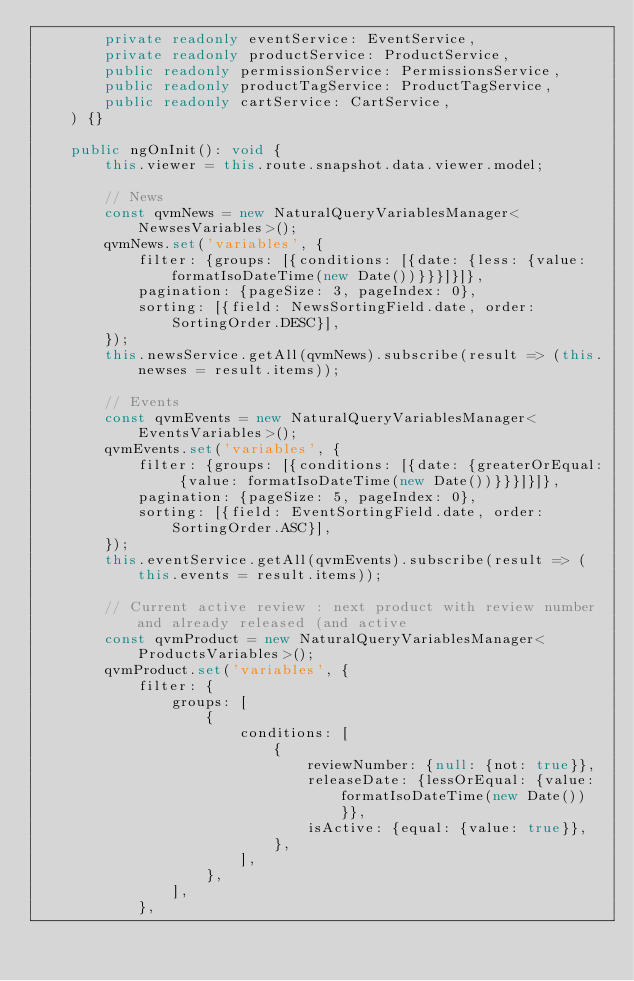Convert code to text. <code><loc_0><loc_0><loc_500><loc_500><_TypeScript_>        private readonly eventService: EventService,
        private readonly productService: ProductService,
        public readonly permissionService: PermissionsService,
        public readonly productTagService: ProductTagService,
        public readonly cartService: CartService,
    ) {}

    public ngOnInit(): void {
        this.viewer = this.route.snapshot.data.viewer.model;

        // News
        const qvmNews = new NaturalQueryVariablesManager<NewsesVariables>();
        qvmNews.set('variables', {
            filter: {groups: [{conditions: [{date: {less: {value: formatIsoDateTime(new Date())}}}]}]},
            pagination: {pageSize: 3, pageIndex: 0},
            sorting: [{field: NewsSortingField.date, order: SortingOrder.DESC}],
        });
        this.newsService.getAll(qvmNews).subscribe(result => (this.newses = result.items));

        // Events
        const qvmEvents = new NaturalQueryVariablesManager<EventsVariables>();
        qvmEvents.set('variables', {
            filter: {groups: [{conditions: [{date: {greaterOrEqual: {value: formatIsoDateTime(new Date())}}}]}]},
            pagination: {pageSize: 5, pageIndex: 0},
            sorting: [{field: EventSortingField.date, order: SortingOrder.ASC}],
        });
        this.eventService.getAll(qvmEvents).subscribe(result => (this.events = result.items));

        // Current active review : next product with review number and already released (and active
        const qvmProduct = new NaturalQueryVariablesManager<ProductsVariables>();
        qvmProduct.set('variables', {
            filter: {
                groups: [
                    {
                        conditions: [
                            {
                                reviewNumber: {null: {not: true}},
                                releaseDate: {lessOrEqual: {value: formatIsoDateTime(new Date())}},
                                isActive: {equal: {value: true}},
                            },
                        ],
                    },
                ],
            },</code> 